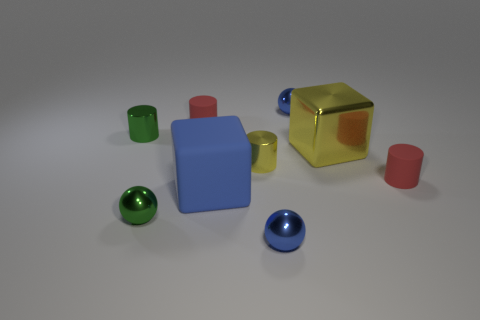Subtract all green metallic cylinders. How many cylinders are left? 3 Add 1 tiny purple metallic cubes. How many objects exist? 10 Subtract all brown blocks. How many blue balls are left? 2 Subtract all yellow cylinders. How many cylinders are left? 3 Subtract all cylinders. How many objects are left? 5 Subtract 1 cubes. How many cubes are left? 1 Subtract all blue cubes. Subtract all green balls. How many cubes are left? 1 Subtract all large yellow shiny things. Subtract all spheres. How many objects are left? 5 Add 3 tiny red things. How many tiny red things are left? 5 Add 4 big yellow shiny cubes. How many big yellow shiny cubes exist? 5 